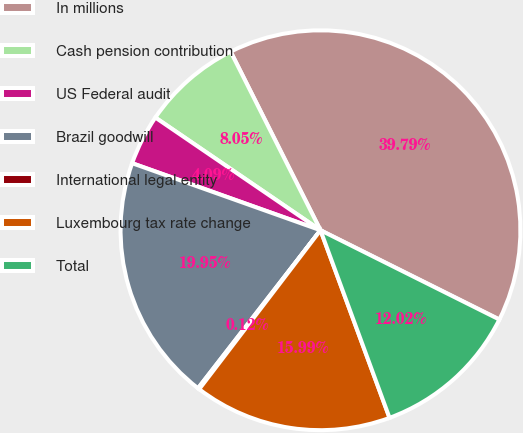Convert chart to OTSL. <chart><loc_0><loc_0><loc_500><loc_500><pie_chart><fcel>In millions<fcel>Cash pension contribution<fcel>US Federal audit<fcel>Brazil goodwill<fcel>International legal entity<fcel>Luxembourg tax rate change<fcel>Total<nl><fcel>39.79%<fcel>8.05%<fcel>4.09%<fcel>19.95%<fcel>0.12%<fcel>15.99%<fcel>12.02%<nl></chart> 